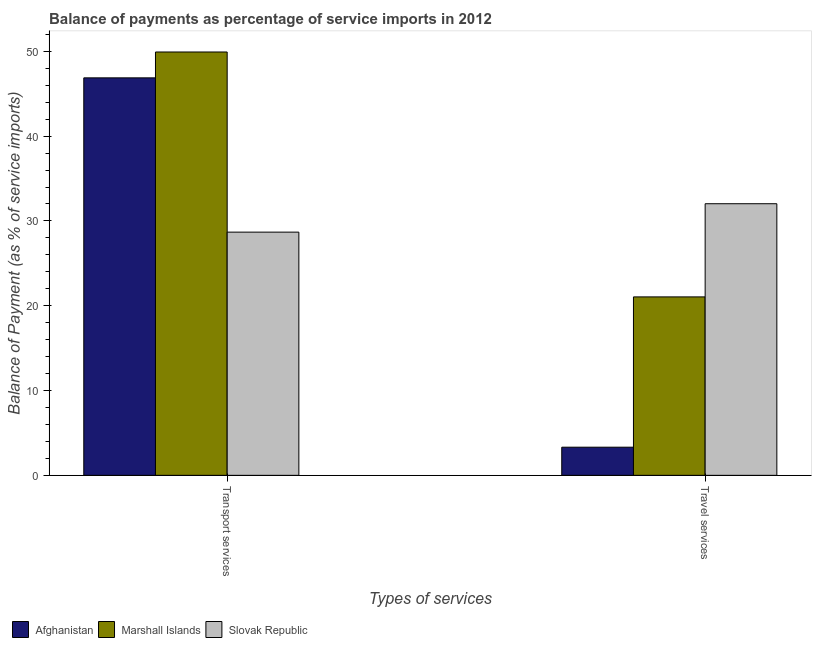How many different coloured bars are there?
Ensure brevity in your answer.  3. How many groups of bars are there?
Your answer should be compact. 2. How many bars are there on the 1st tick from the right?
Provide a short and direct response. 3. What is the label of the 1st group of bars from the left?
Offer a terse response. Transport services. What is the balance of payments of transport services in Marshall Islands?
Keep it short and to the point. 49.92. Across all countries, what is the maximum balance of payments of travel services?
Keep it short and to the point. 32.03. Across all countries, what is the minimum balance of payments of travel services?
Keep it short and to the point. 3.32. In which country was the balance of payments of transport services maximum?
Offer a very short reply. Marshall Islands. In which country was the balance of payments of transport services minimum?
Make the answer very short. Slovak Republic. What is the total balance of payments of transport services in the graph?
Provide a succinct answer. 125.48. What is the difference between the balance of payments of travel services in Marshall Islands and that in Afghanistan?
Give a very brief answer. 17.72. What is the difference between the balance of payments of transport services in Afghanistan and the balance of payments of travel services in Marshall Islands?
Keep it short and to the point. 25.83. What is the average balance of payments of transport services per country?
Your answer should be compact. 41.83. What is the difference between the balance of payments of transport services and balance of payments of travel services in Afghanistan?
Your answer should be compact. 43.56. What is the ratio of the balance of payments of travel services in Afghanistan to that in Marshall Islands?
Your answer should be compact. 0.16. Is the balance of payments of travel services in Marshall Islands less than that in Afghanistan?
Ensure brevity in your answer.  No. In how many countries, is the balance of payments of transport services greater than the average balance of payments of transport services taken over all countries?
Give a very brief answer. 2. What does the 2nd bar from the left in Travel services represents?
Make the answer very short. Marshall Islands. What does the 3rd bar from the right in Transport services represents?
Provide a succinct answer. Afghanistan. How many countries are there in the graph?
Make the answer very short. 3. What is the difference between two consecutive major ticks on the Y-axis?
Offer a terse response. 10. Does the graph contain any zero values?
Give a very brief answer. No. Does the graph contain grids?
Keep it short and to the point. No. Where does the legend appear in the graph?
Provide a short and direct response. Bottom left. How many legend labels are there?
Your answer should be compact. 3. What is the title of the graph?
Provide a short and direct response. Balance of payments as percentage of service imports in 2012. What is the label or title of the X-axis?
Give a very brief answer. Types of services. What is the label or title of the Y-axis?
Provide a succinct answer. Balance of Payment (as % of service imports). What is the Balance of Payment (as % of service imports) of Afghanistan in Transport services?
Ensure brevity in your answer.  46.87. What is the Balance of Payment (as % of service imports) of Marshall Islands in Transport services?
Ensure brevity in your answer.  49.92. What is the Balance of Payment (as % of service imports) in Slovak Republic in Transport services?
Your answer should be very brief. 28.68. What is the Balance of Payment (as % of service imports) in Afghanistan in Travel services?
Make the answer very short. 3.32. What is the Balance of Payment (as % of service imports) in Marshall Islands in Travel services?
Provide a short and direct response. 21.04. What is the Balance of Payment (as % of service imports) in Slovak Republic in Travel services?
Your response must be concise. 32.03. Across all Types of services, what is the maximum Balance of Payment (as % of service imports) in Afghanistan?
Give a very brief answer. 46.87. Across all Types of services, what is the maximum Balance of Payment (as % of service imports) of Marshall Islands?
Offer a very short reply. 49.92. Across all Types of services, what is the maximum Balance of Payment (as % of service imports) of Slovak Republic?
Offer a terse response. 32.03. Across all Types of services, what is the minimum Balance of Payment (as % of service imports) of Afghanistan?
Your response must be concise. 3.32. Across all Types of services, what is the minimum Balance of Payment (as % of service imports) in Marshall Islands?
Keep it short and to the point. 21.04. Across all Types of services, what is the minimum Balance of Payment (as % of service imports) of Slovak Republic?
Provide a short and direct response. 28.68. What is the total Balance of Payment (as % of service imports) in Afghanistan in the graph?
Ensure brevity in your answer.  50.19. What is the total Balance of Payment (as % of service imports) of Marshall Islands in the graph?
Your answer should be compact. 70.97. What is the total Balance of Payment (as % of service imports) of Slovak Republic in the graph?
Provide a succinct answer. 60.71. What is the difference between the Balance of Payment (as % of service imports) of Afghanistan in Transport services and that in Travel services?
Your answer should be very brief. 43.56. What is the difference between the Balance of Payment (as % of service imports) of Marshall Islands in Transport services and that in Travel services?
Provide a succinct answer. 28.88. What is the difference between the Balance of Payment (as % of service imports) of Slovak Republic in Transport services and that in Travel services?
Give a very brief answer. -3.35. What is the difference between the Balance of Payment (as % of service imports) of Afghanistan in Transport services and the Balance of Payment (as % of service imports) of Marshall Islands in Travel services?
Offer a terse response. 25.83. What is the difference between the Balance of Payment (as % of service imports) in Afghanistan in Transport services and the Balance of Payment (as % of service imports) in Slovak Republic in Travel services?
Give a very brief answer. 14.84. What is the difference between the Balance of Payment (as % of service imports) in Marshall Islands in Transport services and the Balance of Payment (as % of service imports) in Slovak Republic in Travel services?
Your answer should be very brief. 17.89. What is the average Balance of Payment (as % of service imports) of Afghanistan per Types of services?
Offer a terse response. 25.1. What is the average Balance of Payment (as % of service imports) of Marshall Islands per Types of services?
Offer a terse response. 35.48. What is the average Balance of Payment (as % of service imports) in Slovak Republic per Types of services?
Ensure brevity in your answer.  30.36. What is the difference between the Balance of Payment (as % of service imports) in Afghanistan and Balance of Payment (as % of service imports) in Marshall Islands in Transport services?
Ensure brevity in your answer.  -3.05. What is the difference between the Balance of Payment (as % of service imports) of Afghanistan and Balance of Payment (as % of service imports) of Slovak Republic in Transport services?
Offer a very short reply. 18.19. What is the difference between the Balance of Payment (as % of service imports) in Marshall Islands and Balance of Payment (as % of service imports) in Slovak Republic in Transport services?
Make the answer very short. 21.24. What is the difference between the Balance of Payment (as % of service imports) of Afghanistan and Balance of Payment (as % of service imports) of Marshall Islands in Travel services?
Make the answer very short. -17.72. What is the difference between the Balance of Payment (as % of service imports) of Afghanistan and Balance of Payment (as % of service imports) of Slovak Republic in Travel services?
Keep it short and to the point. -28.71. What is the difference between the Balance of Payment (as % of service imports) in Marshall Islands and Balance of Payment (as % of service imports) in Slovak Republic in Travel services?
Provide a succinct answer. -10.99. What is the ratio of the Balance of Payment (as % of service imports) of Afghanistan in Transport services to that in Travel services?
Offer a very short reply. 14.12. What is the ratio of the Balance of Payment (as % of service imports) of Marshall Islands in Transport services to that in Travel services?
Offer a very short reply. 2.37. What is the ratio of the Balance of Payment (as % of service imports) in Slovak Republic in Transport services to that in Travel services?
Your answer should be very brief. 0.9. What is the difference between the highest and the second highest Balance of Payment (as % of service imports) in Afghanistan?
Offer a very short reply. 43.56. What is the difference between the highest and the second highest Balance of Payment (as % of service imports) of Marshall Islands?
Provide a short and direct response. 28.88. What is the difference between the highest and the second highest Balance of Payment (as % of service imports) of Slovak Republic?
Offer a terse response. 3.35. What is the difference between the highest and the lowest Balance of Payment (as % of service imports) in Afghanistan?
Ensure brevity in your answer.  43.56. What is the difference between the highest and the lowest Balance of Payment (as % of service imports) of Marshall Islands?
Provide a short and direct response. 28.88. What is the difference between the highest and the lowest Balance of Payment (as % of service imports) in Slovak Republic?
Your answer should be compact. 3.35. 